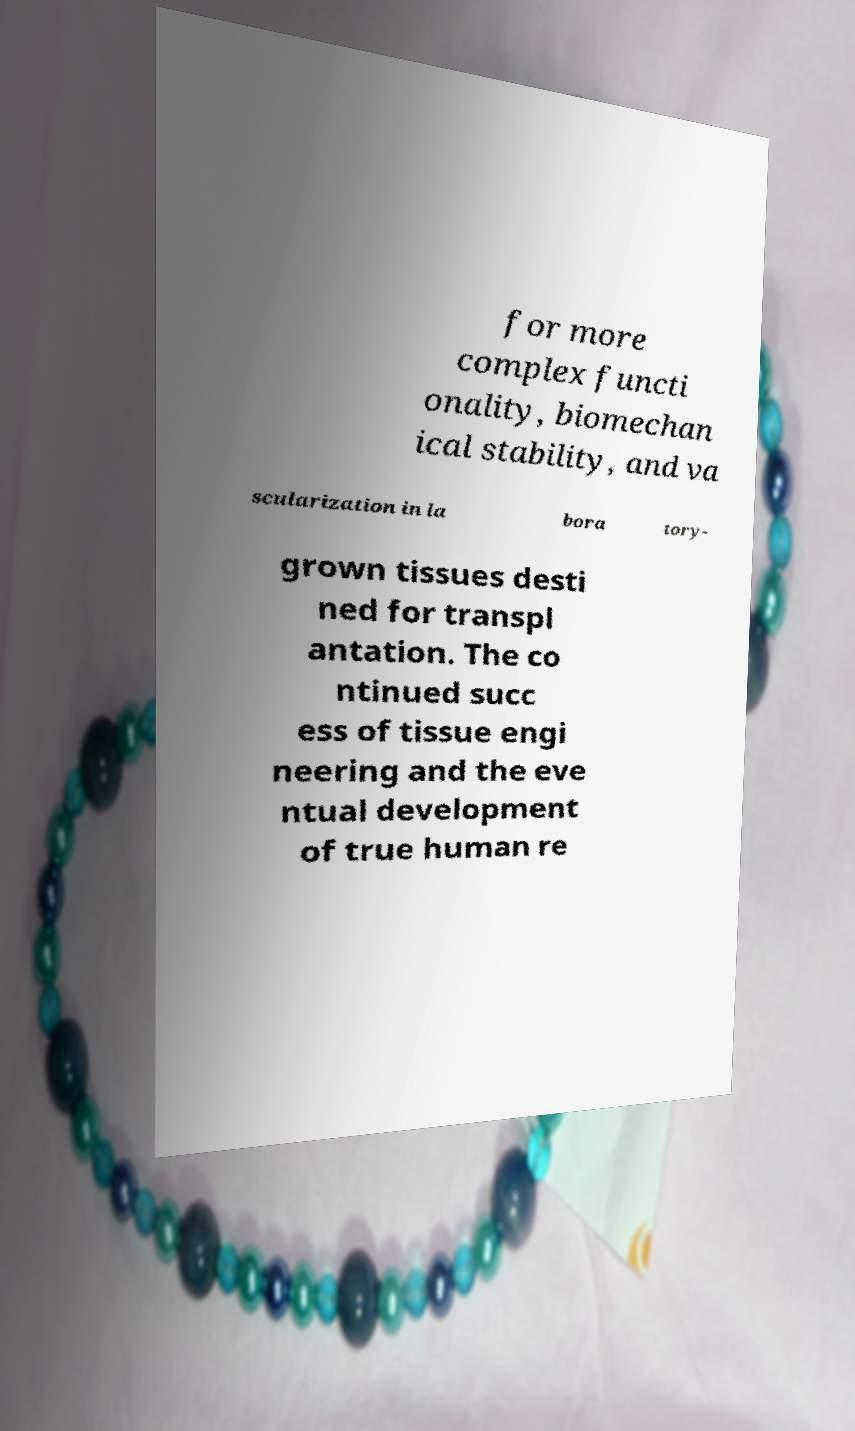For documentation purposes, I need the text within this image transcribed. Could you provide that? for more complex functi onality, biomechan ical stability, and va scularization in la bora tory- grown tissues desti ned for transpl antation. The co ntinued succ ess of tissue engi neering and the eve ntual development of true human re 